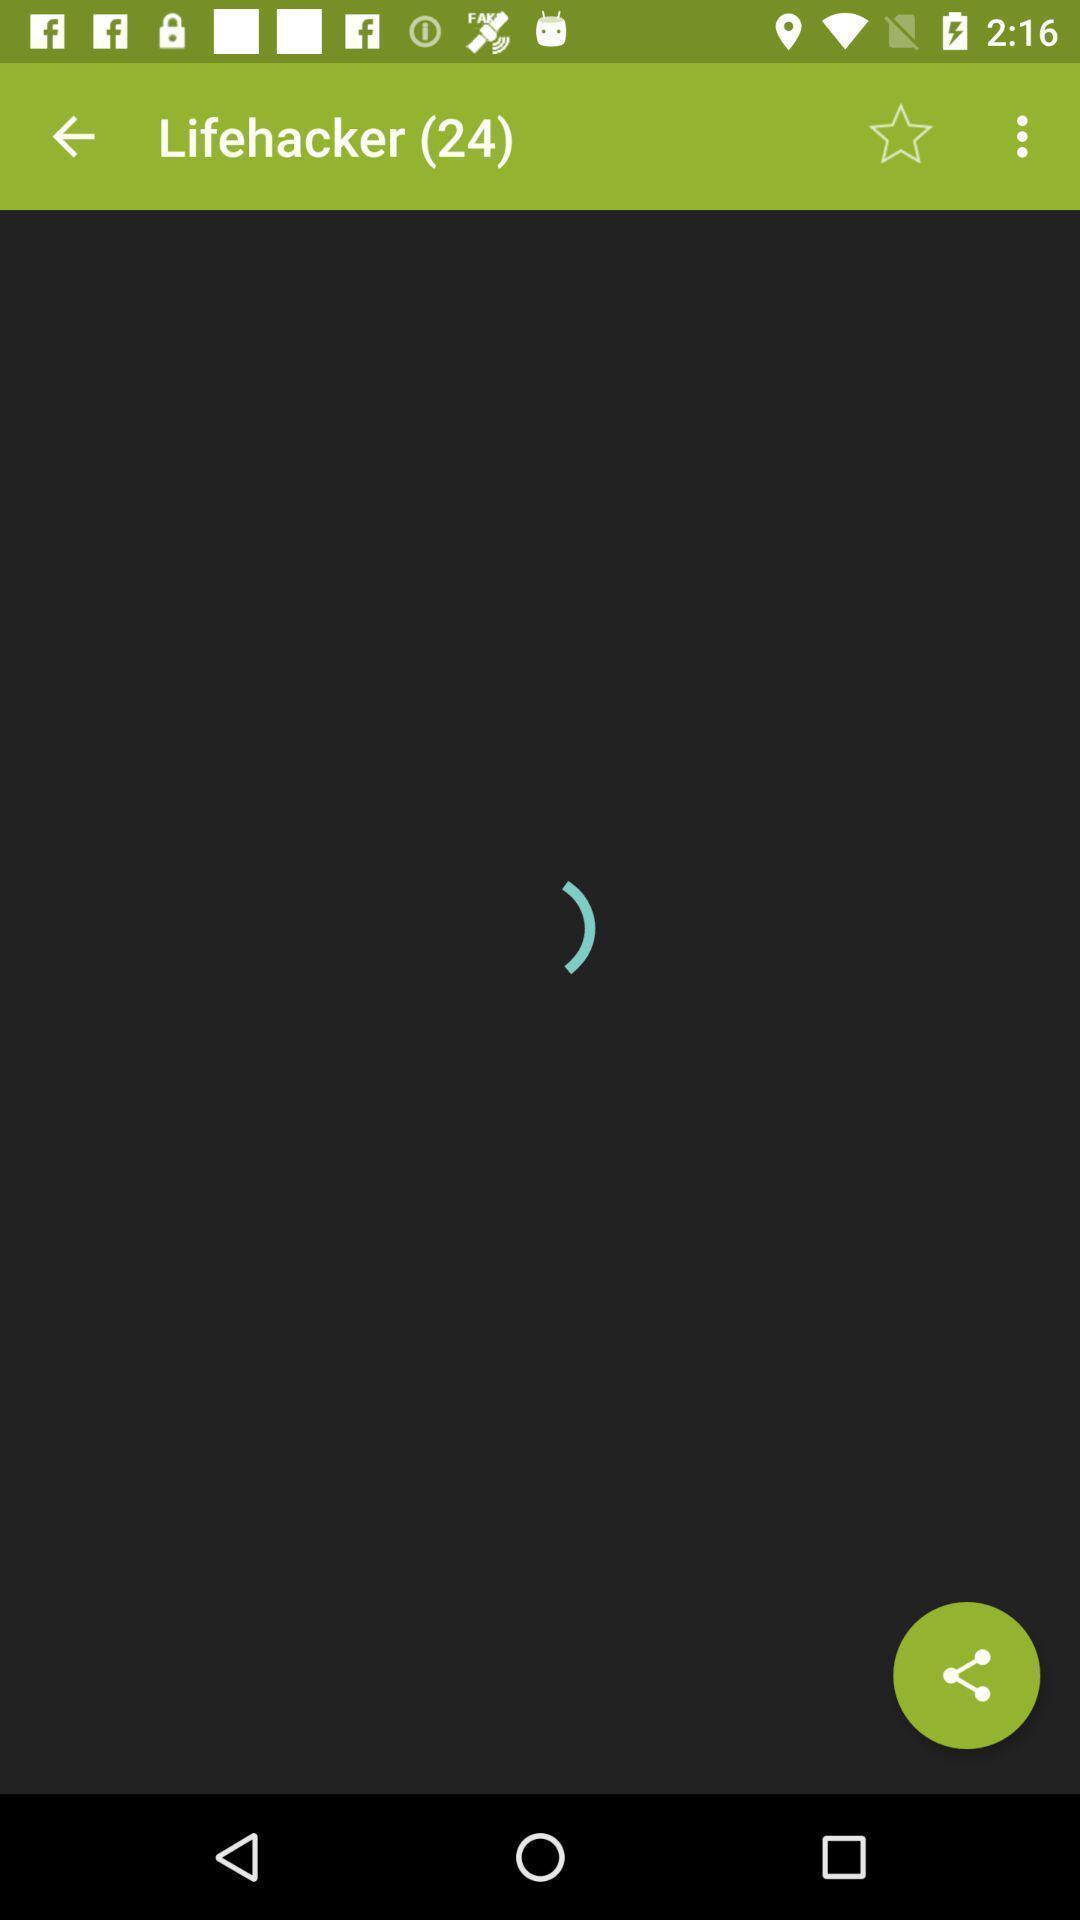Tell me what you see in this picture. Screen showing loading of page. 